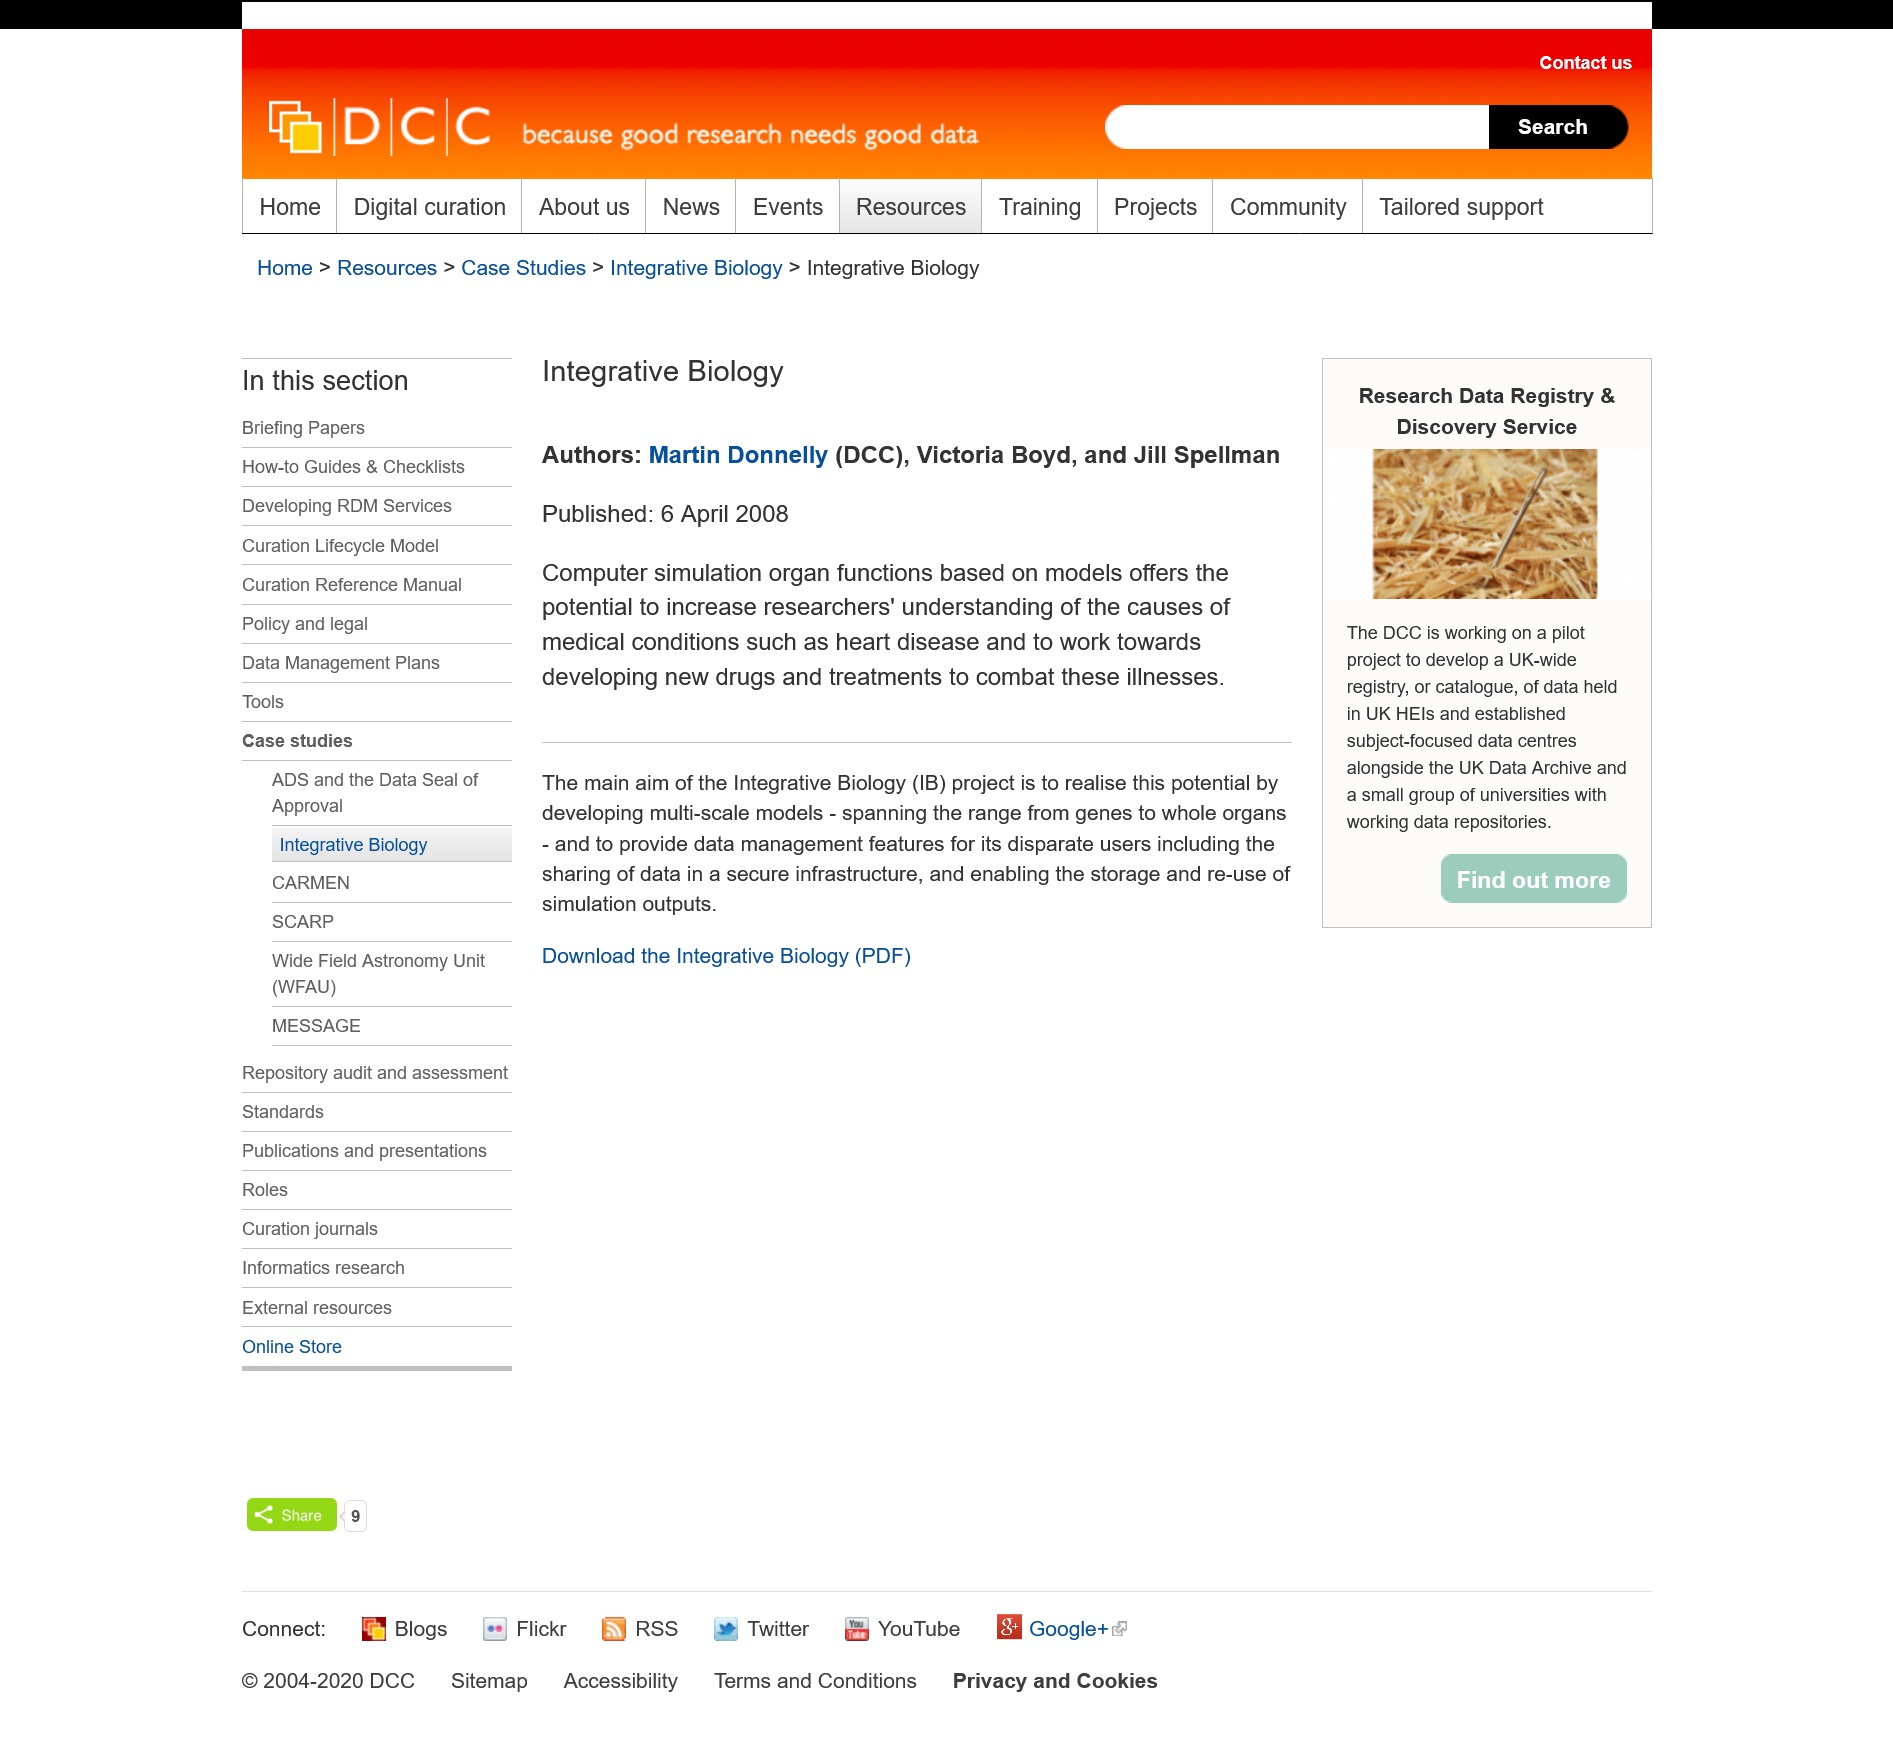Mention a couple of crucial points in this snapshot. The text was published in 2008. The text has three authors. The text mentions heart disease. 